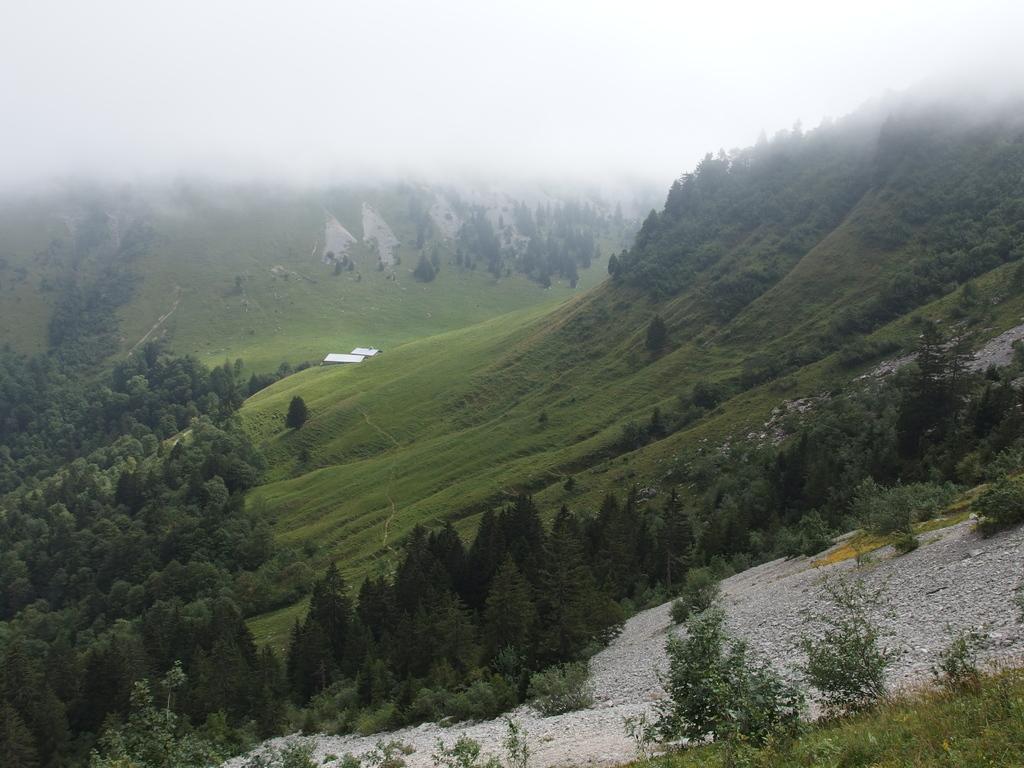Can you describe this image briefly? In this image, we can see trees and some plants. In the background, there are hills. 